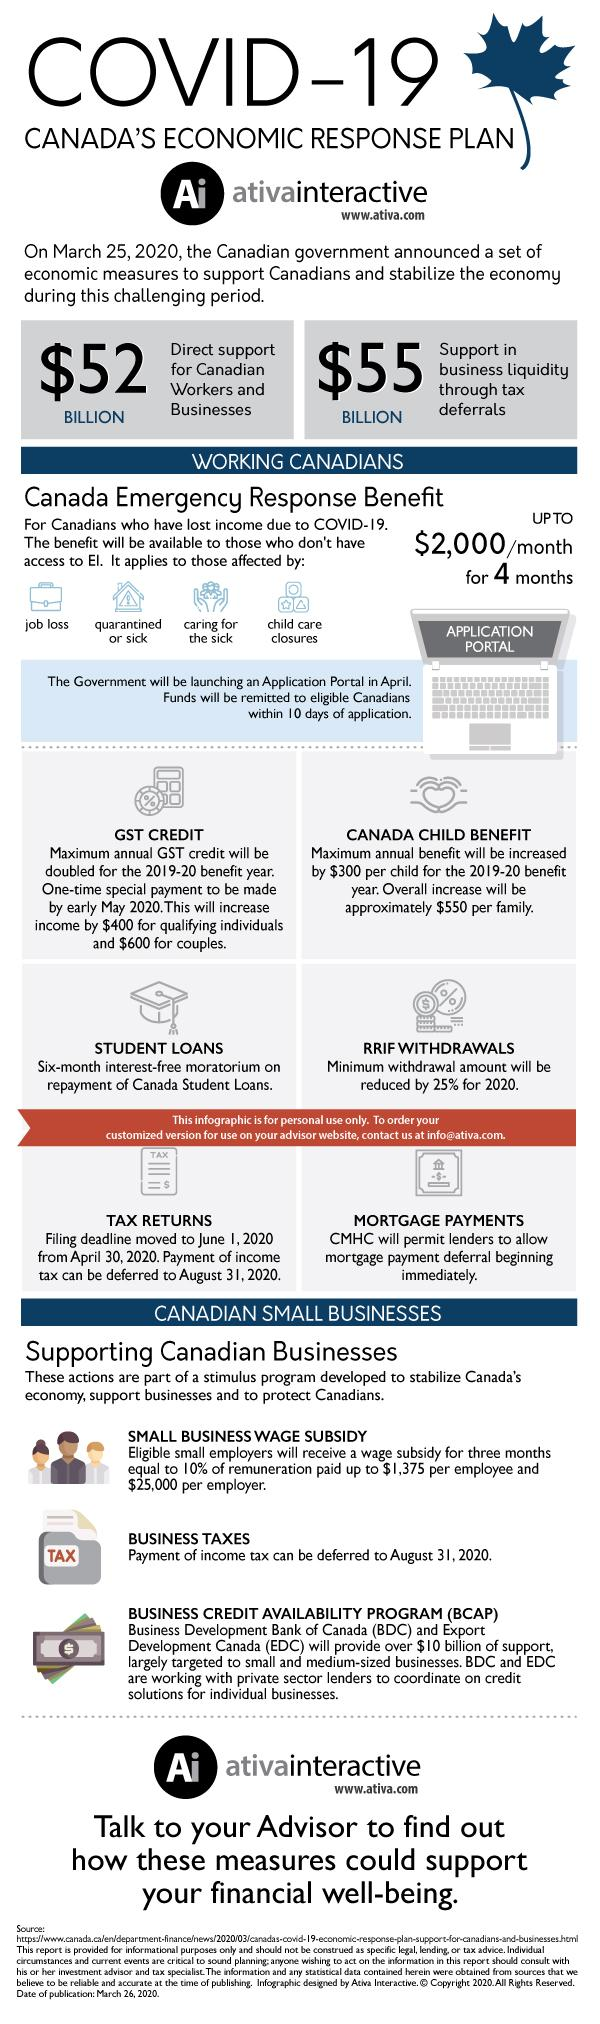Specify some key components in this picture. The written content on the laptop is called "Application Portal". Job loss is represented using a symbol-bag, or money bag, to indicate the financial impact on the individual and their family. The symbol that is typically found on money is the dollar sign ($). 